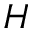<formula> <loc_0><loc_0><loc_500><loc_500>H</formula> 